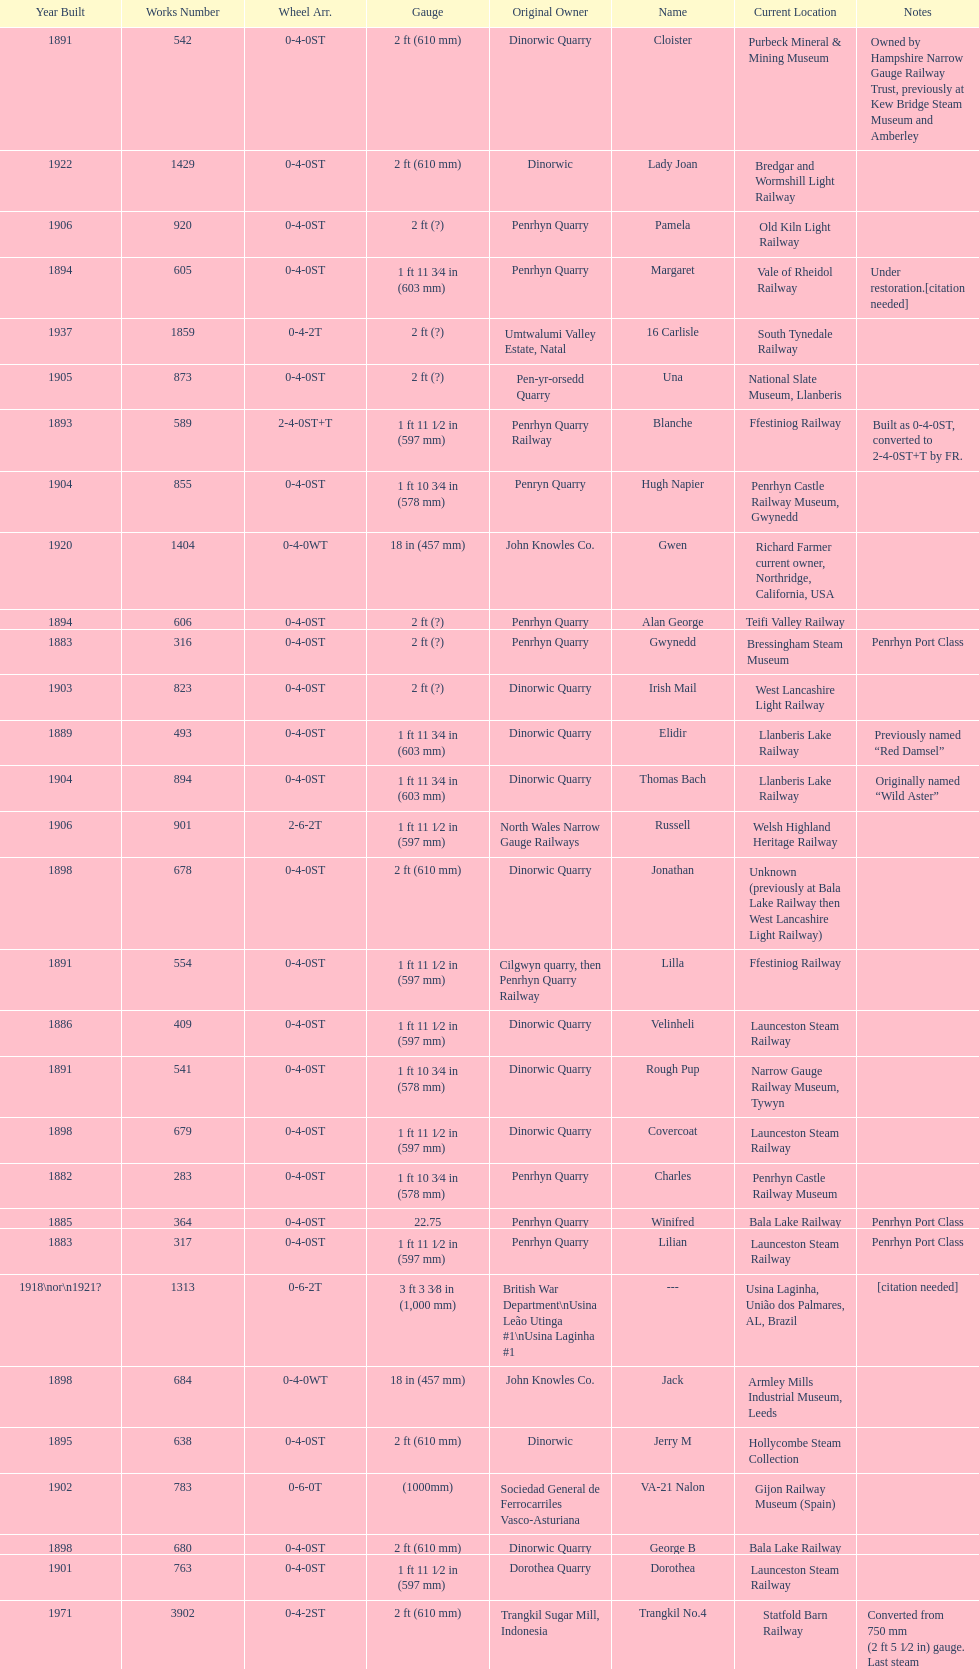What is the total number of preserved hunslet narrow gauge locomotives currently located in ffestiniog railway 554. 